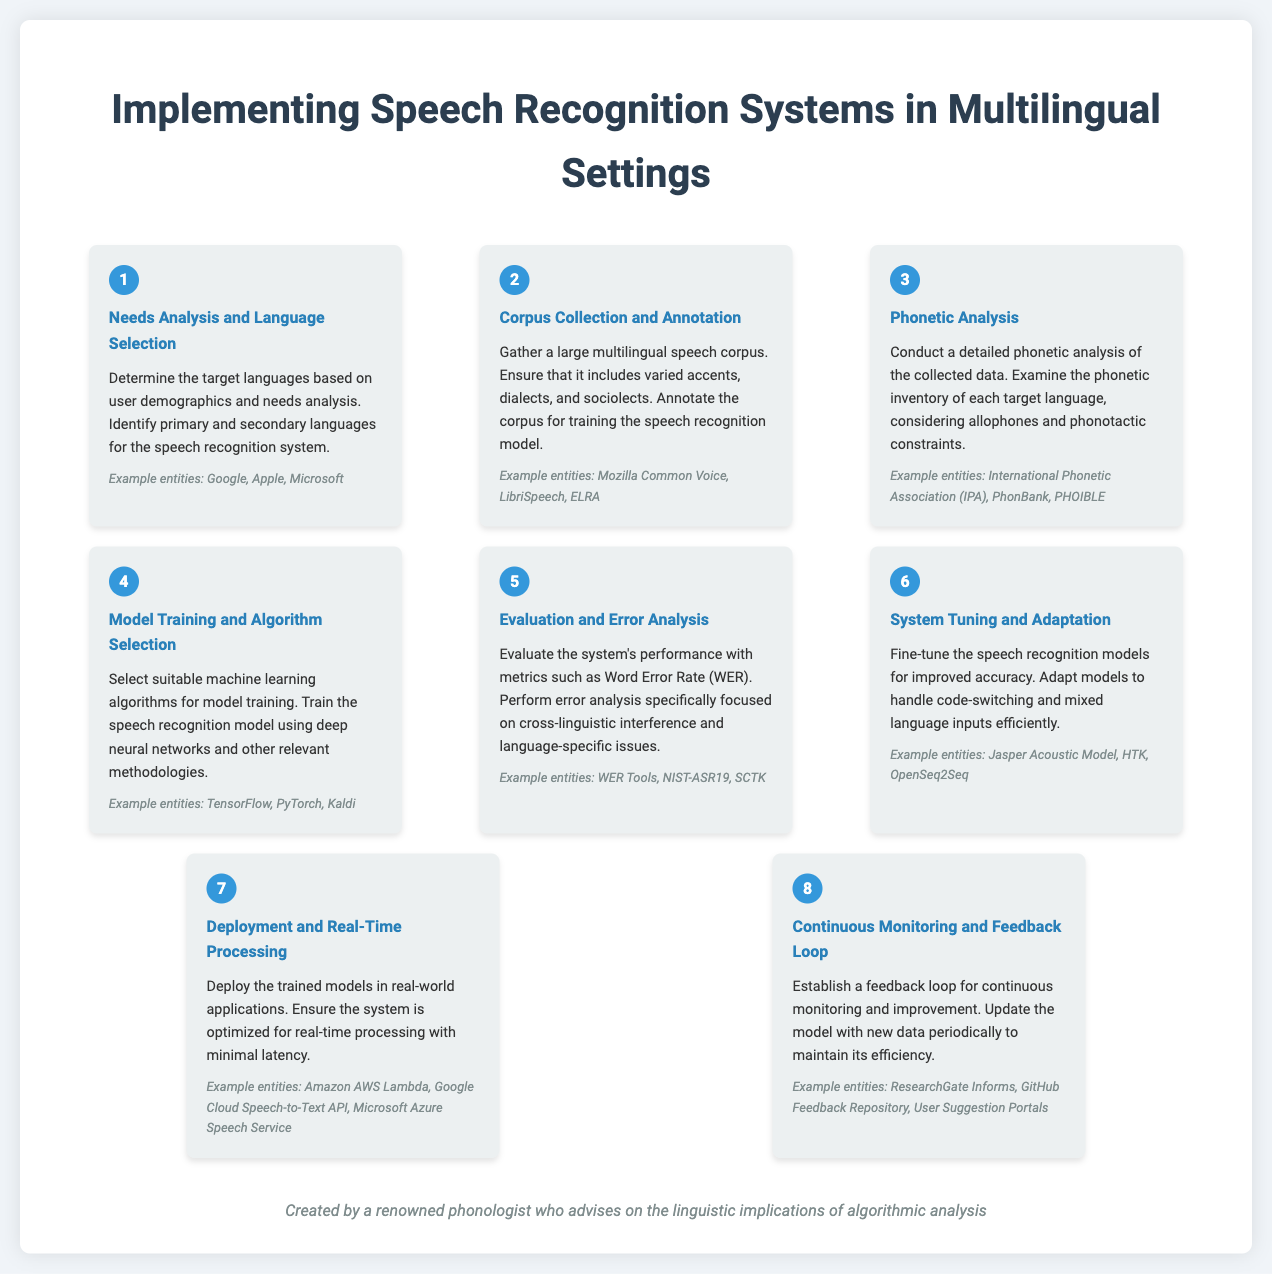What is the first step in the process? The first step in the process is "Needs Analysis and Language Selection," which determines the target languages based on user demographics.
Answer: Needs Analysis and Language Selection What example entities are listed for Corpus Collection and Annotation? The example entities listed for that step are "Mozilla Common Voice, LibriSpeech, ELRA."
Answer: Mozilla Common Voice, LibriSpeech, ELRA How many steps are outlined in the document? The total number of steps outlined in the document is eight, as indicated by the steps counted.
Answer: 8 What is the main focus of the Evaluation and Error Analysis step? The main focus of this step is to evaluate the system's performance specifically on "cross-linguistic interference and language-specific issues."
Answer: cross-linguistic interference and language-specific issues Which step involves fine-tuning for code-switching? The step that involves fine-tuning for code-switching is "System Tuning and Adaptation."
Answer: System Tuning and Adaptation What metrics are used for evaluation in the Evaluation and Error Analysis step? The metrics used for evaluation in this step include "Word Error Rate (WER)."
Answer: Word Error Rate (WER) Which technology is mentioned for deployment in real-time processing? The technology mentioned for deployment in real-time processing is "Google Cloud Speech-to-Text API."
Answer: Google Cloud Speech-to-Text API What does the feedback loop in Continuous Monitoring and Feedback Loop aim to achieve? The feedback loop in this step aims for "continuous monitoring and improvement" of the system.
Answer: continuous monitoring and improvement 